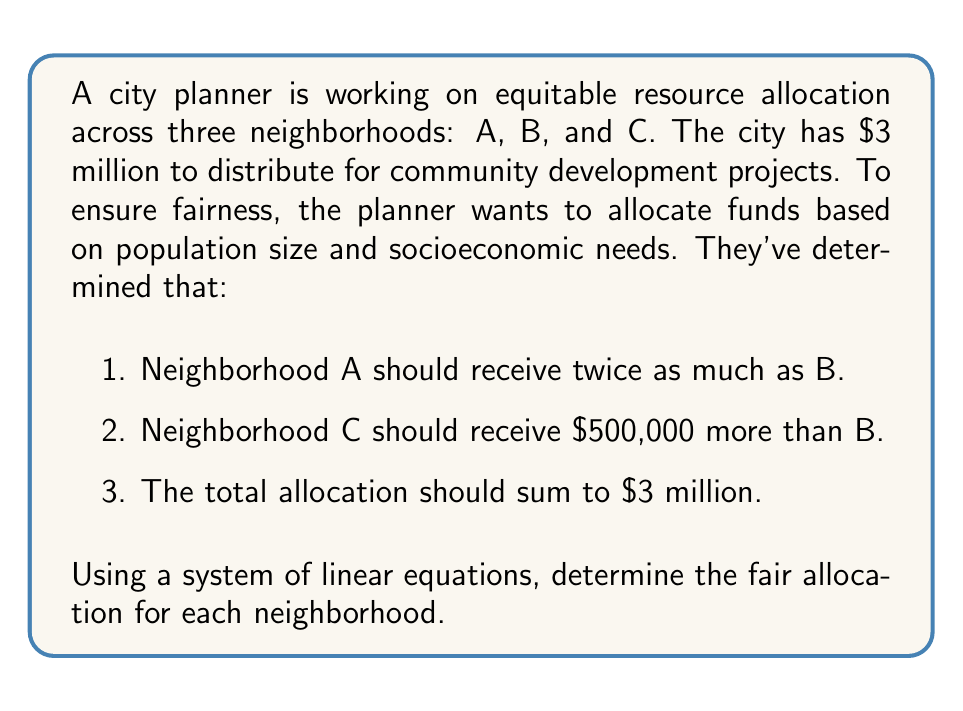Solve this math problem. Let's approach this step-by-step:

1. Define variables:
   Let $x$ = allocation for Neighborhood B
   Then, $2x$ = allocation for Neighborhood A
   And $x + 500,000$ = allocation for Neighborhood C

2. Set up the system of linear equations:
   $$2x + x + (x + 500,000) = 3,000,000$$

3. Simplify the equation:
   $$4x + 500,000 = 3,000,000$$

4. Subtract 500,000 from both sides:
   $$4x = 2,500,000$$

5. Divide both sides by 4:
   $$x = 625,000$$

6. Now that we know $x$, we can calculate the allocations for A and C:
   Neighborhood A: $2x = 2(625,000) = 1,250,000$
   Neighborhood B: $x = 625,000$
   Neighborhood C: $x + 500,000 = 625,000 + 500,000 = 1,125,000$

7. Verify the total:
   $$1,250,000 + 625,000 + 1,125,000 = 3,000,000$$

The fair allocation based on the given criteria is:
Neighborhood A: $1,250,000
Neighborhood B: $625,000
Neighborhood C: $1,125,000
Answer: A: $1,250,000, B: $625,000, C: $1,125,000 